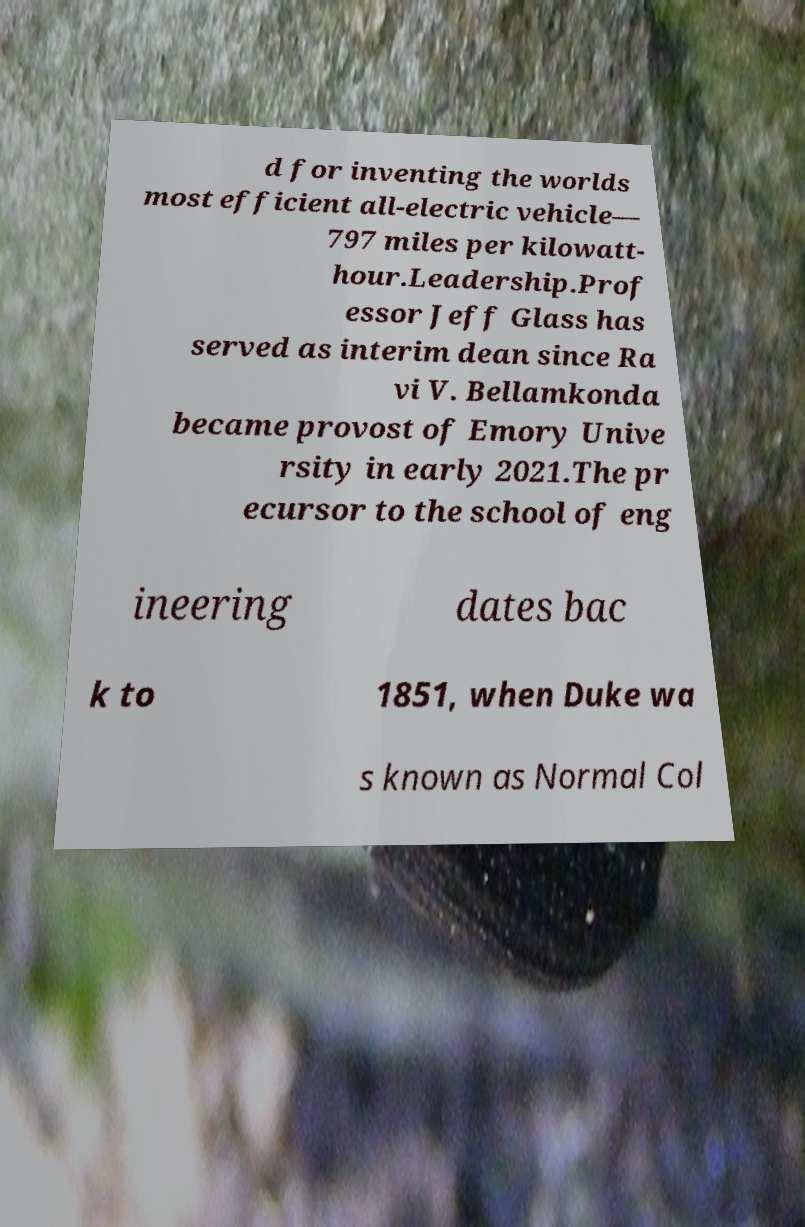For documentation purposes, I need the text within this image transcribed. Could you provide that? d for inventing the worlds most efficient all-electric vehicle— 797 miles per kilowatt- hour.Leadership.Prof essor Jeff Glass has served as interim dean since Ra vi V. Bellamkonda became provost of Emory Unive rsity in early 2021.The pr ecursor to the school of eng ineering dates bac k to 1851, when Duke wa s known as Normal Col 